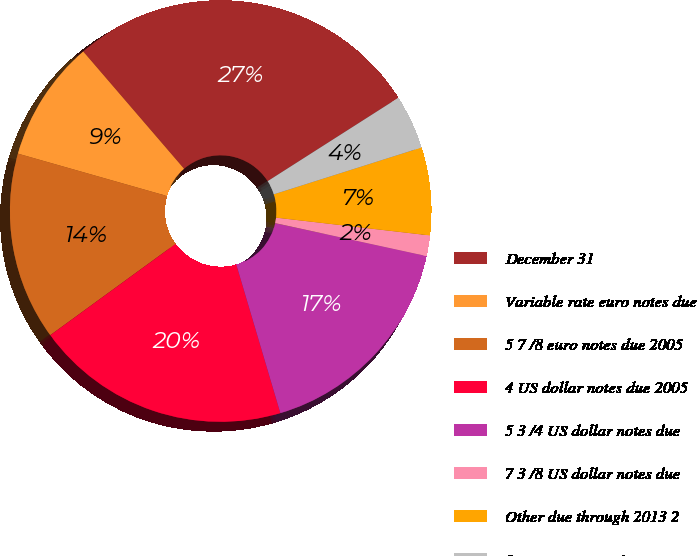<chart> <loc_0><loc_0><loc_500><loc_500><pie_chart><fcel>December 31<fcel>Variable rate euro notes due<fcel>5 7 /8 euro notes due 2005<fcel>4 US dollar notes due 2005<fcel>5 3 /4 US dollar notes due<fcel>7 3 /8 US dollar notes due<fcel>Other due through 2013 2<fcel>Less current portion<nl><fcel>27.27%<fcel>9.29%<fcel>14.43%<fcel>19.57%<fcel>17.0%<fcel>1.58%<fcel>6.72%<fcel>4.15%<nl></chart> 